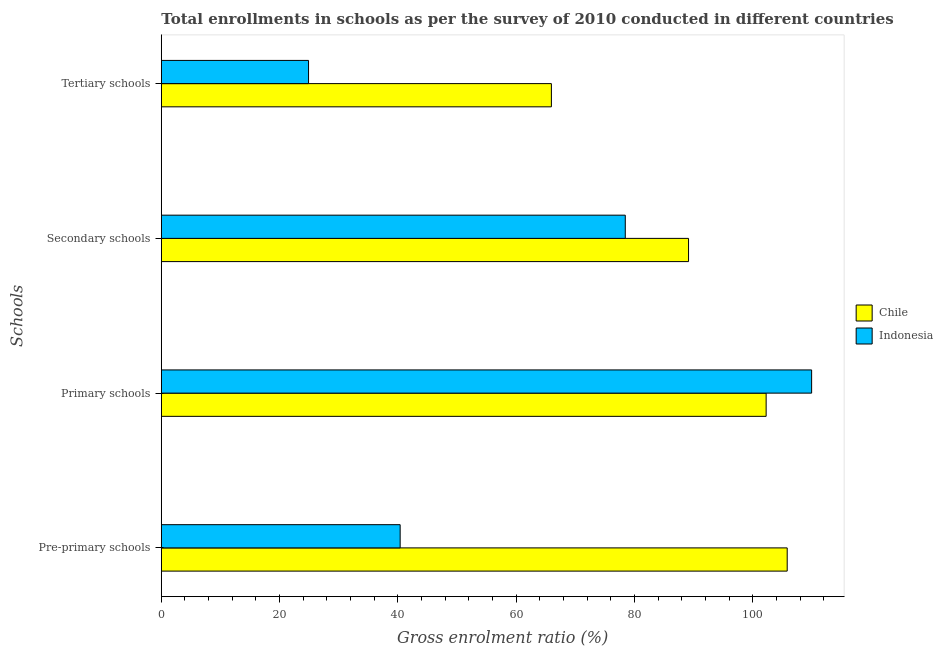How many different coloured bars are there?
Make the answer very short. 2. How many groups of bars are there?
Your answer should be compact. 4. Are the number of bars per tick equal to the number of legend labels?
Ensure brevity in your answer.  Yes. Are the number of bars on each tick of the Y-axis equal?
Provide a succinct answer. Yes. What is the label of the 2nd group of bars from the top?
Your response must be concise. Secondary schools. What is the gross enrolment ratio in primary schools in Chile?
Keep it short and to the point. 102.23. Across all countries, what is the maximum gross enrolment ratio in tertiary schools?
Offer a terse response. 65.93. Across all countries, what is the minimum gross enrolment ratio in tertiary schools?
Make the answer very short. 24.89. What is the total gross enrolment ratio in pre-primary schools in the graph?
Ensure brevity in your answer.  146.17. What is the difference between the gross enrolment ratio in pre-primary schools in Indonesia and that in Chile?
Your answer should be compact. -65.42. What is the difference between the gross enrolment ratio in tertiary schools in Indonesia and the gross enrolment ratio in primary schools in Chile?
Make the answer very short. -77.35. What is the average gross enrolment ratio in primary schools per country?
Your answer should be very brief. 106.08. What is the difference between the gross enrolment ratio in primary schools and gross enrolment ratio in secondary schools in Chile?
Offer a very short reply. 13.11. In how many countries, is the gross enrolment ratio in primary schools greater than 20 %?
Offer a very short reply. 2. What is the ratio of the gross enrolment ratio in secondary schools in Chile to that in Indonesia?
Give a very brief answer. 1.14. Is the gross enrolment ratio in primary schools in Chile less than that in Indonesia?
Your response must be concise. Yes. What is the difference between the highest and the second highest gross enrolment ratio in primary schools?
Give a very brief answer. 7.69. What is the difference between the highest and the lowest gross enrolment ratio in secondary schools?
Offer a very short reply. 10.69. Is the sum of the gross enrolment ratio in secondary schools in Chile and Indonesia greater than the maximum gross enrolment ratio in pre-primary schools across all countries?
Keep it short and to the point. Yes. Is it the case that in every country, the sum of the gross enrolment ratio in pre-primary schools and gross enrolment ratio in primary schools is greater than the sum of gross enrolment ratio in tertiary schools and gross enrolment ratio in secondary schools?
Provide a short and direct response. Yes. What does the 1st bar from the bottom in Pre-primary schools represents?
Your response must be concise. Chile. How many bars are there?
Offer a very short reply. 8. How many countries are there in the graph?
Offer a very short reply. 2. Does the graph contain any zero values?
Make the answer very short. No. How are the legend labels stacked?
Provide a succinct answer. Vertical. What is the title of the graph?
Your answer should be compact. Total enrollments in schools as per the survey of 2010 conducted in different countries. What is the label or title of the Y-axis?
Provide a short and direct response. Schools. What is the Gross enrolment ratio (%) of Chile in Pre-primary schools?
Offer a very short reply. 105.79. What is the Gross enrolment ratio (%) of Indonesia in Pre-primary schools?
Keep it short and to the point. 40.37. What is the Gross enrolment ratio (%) of Chile in Primary schools?
Your answer should be compact. 102.23. What is the Gross enrolment ratio (%) of Indonesia in Primary schools?
Provide a succinct answer. 109.92. What is the Gross enrolment ratio (%) of Chile in Secondary schools?
Keep it short and to the point. 89.12. What is the Gross enrolment ratio (%) in Indonesia in Secondary schools?
Offer a very short reply. 78.43. What is the Gross enrolment ratio (%) of Chile in Tertiary schools?
Your response must be concise. 65.93. What is the Gross enrolment ratio (%) of Indonesia in Tertiary schools?
Keep it short and to the point. 24.89. Across all Schools, what is the maximum Gross enrolment ratio (%) of Chile?
Give a very brief answer. 105.79. Across all Schools, what is the maximum Gross enrolment ratio (%) of Indonesia?
Give a very brief answer. 109.92. Across all Schools, what is the minimum Gross enrolment ratio (%) of Chile?
Provide a short and direct response. 65.93. Across all Schools, what is the minimum Gross enrolment ratio (%) in Indonesia?
Provide a succinct answer. 24.89. What is the total Gross enrolment ratio (%) of Chile in the graph?
Offer a terse response. 363.08. What is the total Gross enrolment ratio (%) in Indonesia in the graph?
Provide a short and direct response. 253.61. What is the difference between the Gross enrolment ratio (%) of Chile in Pre-primary schools and that in Primary schools?
Keep it short and to the point. 3.56. What is the difference between the Gross enrolment ratio (%) in Indonesia in Pre-primary schools and that in Primary schools?
Make the answer very short. -69.55. What is the difference between the Gross enrolment ratio (%) in Chile in Pre-primary schools and that in Secondary schools?
Your response must be concise. 16.67. What is the difference between the Gross enrolment ratio (%) in Indonesia in Pre-primary schools and that in Secondary schools?
Your response must be concise. -38.05. What is the difference between the Gross enrolment ratio (%) of Chile in Pre-primary schools and that in Tertiary schools?
Provide a short and direct response. 39.86. What is the difference between the Gross enrolment ratio (%) in Indonesia in Pre-primary schools and that in Tertiary schools?
Offer a terse response. 15.49. What is the difference between the Gross enrolment ratio (%) in Chile in Primary schools and that in Secondary schools?
Your response must be concise. 13.11. What is the difference between the Gross enrolment ratio (%) of Indonesia in Primary schools and that in Secondary schools?
Your response must be concise. 31.5. What is the difference between the Gross enrolment ratio (%) in Chile in Primary schools and that in Tertiary schools?
Offer a very short reply. 36.3. What is the difference between the Gross enrolment ratio (%) in Indonesia in Primary schools and that in Tertiary schools?
Offer a terse response. 85.04. What is the difference between the Gross enrolment ratio (%) in Chile in Secondary schools and that in Tertiary schools?
Your answer should be compact. 23.19. What is the difference between the Gross enrolment ratio (%) in Indonesia in Secondary schools and that in Tertiary schools?
Make the answer very short. 53.54. What is the difference between the Gross enrolment ratio (%) in Chile in Pre-primary schools and the Gross enrolment ratio (%) in Indonesia in Primary schools?
Offer a terse response. -4.13. What is the difference between the Gross enrolment ratio (%) of Chile in Pre-primary schools and the Gross enrolment ratio (%) of Indonesia in Secondary schools?
Keep it short and to the point. 27.37. What is the difference between the Gross enrolment ratio (%) in Chile in Pre-primary schools and the Gross enrolment ratio (%) in Indonesia in Tertiary schools?
Keep it short and to the point. 80.91. What is the difference between the Gross enrolment ratio (%) in Chile in Primary schools and the Gross enrolment ratio (%) in Indonesia in Secondary schools?
Provide a short and direct response. 23.81. What is the difference between the Gross enrolment ratio (%) of Chile in Primary schools and the Gross enrolment ratio (%) of Indonesia in Tertiary schools?
Provide a short and direct response. 77.35. What is the difference between the Gross enrolment ratio (%) of Chile in Secondary schools and the Gross enrolment ratio (%) of Indonesia in Tertiary schools?
Keep it short and to the point. 64.23. What is the average Gross enrolment ratio (%) in Chile per Schools?
Your answer should be compact. 90.77. What is the average Gross enrolment ratio (%) in Indonesia per Schools?
Provide a succinct answer. 63.4. What is the difference between the Gross enrolment ratio (%) of Chile and Gross enrolment ratio (%) of Indonesia in Pre-primary schools?
Your answer should be very brief. 65.42. What is the difference between the Gross enrolment ratio (%) of Chile and Gross enrolment ratio (%) of Indonesia in Primary schools?
Make the answer very short. -7.69. What is the difference between the Gross enrolment ratio (%) in Chile and Gross enrolment ratio (%) in Indonesia in Secondary schools?
Ensure brevity in your answer.  10.69. What is the difference between the Gross enrolment ratio (%) in Chile and Gross enrolment ratio (%) in Indonesia in Tertiary schools?
Provide a short and direct response. 41.05. What is the ratio of the Gross enrolment ratio (%) of Chile in Pre-primary schools to that in Primary schools?
Provide a succinct answer. 1.03. What is the ratio of the Gross enrolment ratio (%) of Indonesia in Pre-primary schools to that in Primary schools?
Ensure brevity in your answer.  0.37. What is the ratio of the Gross enrolment ratio (%) of Chile in Pre-primary schools to that in Secondary schools?
Keep it short and to the point. 1.19. What is the ratio of the Gross enrolment ratio (%) in Indonesia in Pre-primary schools to that in Secondary schools?
Your answer should be very brief. 0.51. What is the ratio of the Gross enrolment ratio (%) of Chile in Pre-primary schools to that in Tertiary schools?
Your response must be concise. 1.6. What is the ratio of the Gross enrolment ratio (%) in Indonesia in Pre-primary schools to that in Tertiary schools?
Keep it short and to the point. 1.62. What is the ratio of the Gross enrolment ratio (%) in Chile in Primary schools to that in Secondary schools?
Your answer should be compact. 1.15. What is the ratio of the Gross enrolment ratio (%) of Indonesia in Primary schools to that in Secondary schools?
Provide a succinct answer. 1.4. What is the ratio of the Gross enrolment ratio (%) of Chile in Primary schools to that in Tertiary schools?
Keep it short and to the point. 1.55. What is the ratio of the Gross enrolment ratio (%) of Indonesia in Primary schools to that in Tertiary schools?
Give a very brief answer. 4.42. What is the ratio of the Gross enrolment ratio (%) of Chile in Secondary schools to that in Tertiary schools?
Give a very brief answer. 1.35. What is the ratio of the Gross enrolment ratio (%) in Indonesia in Secondary schools to that in Tertiary schools?
Provide a short and direct response. 3.15. What is the difference between the highest and the second highest Gross enrolment ratio (%) of Chile?
Offer a very short reply. 3.56. What is the difference between the highest and the second highest Gross enrolment ratio (%) in Indonesia?
Your response must be concise. 31.5. What is the difference between the highest and the lowest Gross enrolment ratio (%) of Chile?
Your answer should be very brief. 39.86. What is the difference between the highest and the lowest Gross enrolment ratio (%) in Indonesia?
Your answer should be very brief. 85.04. 